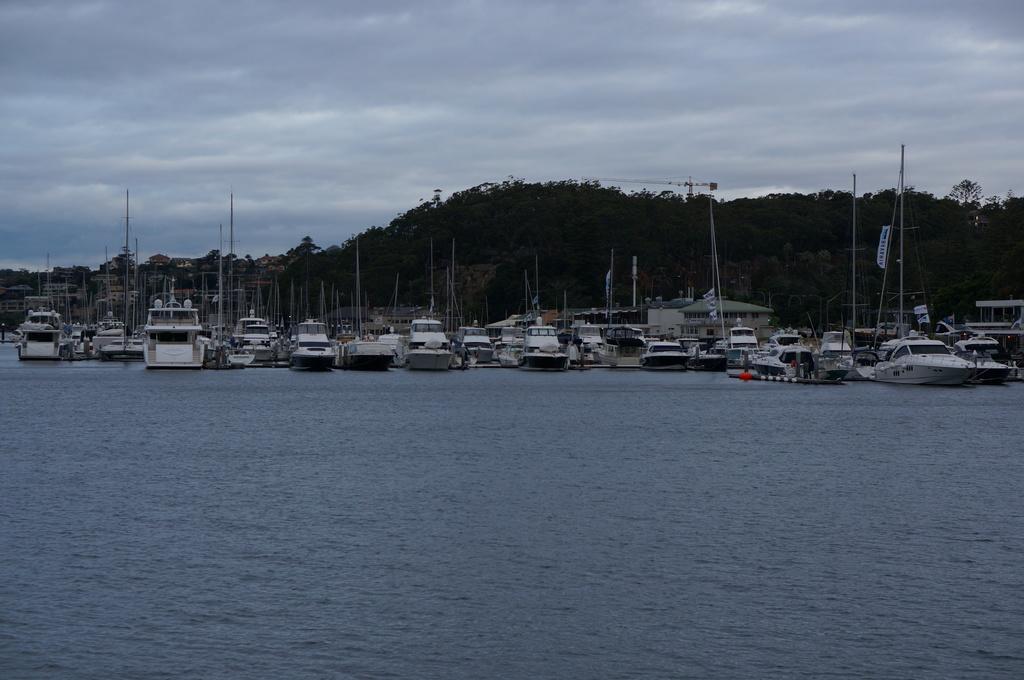Describe this image in one or two sentences. In this image at the bottom there is a sea and in that sea there are some boats, and in the background there are some trees. At the top of the image there is sky. 